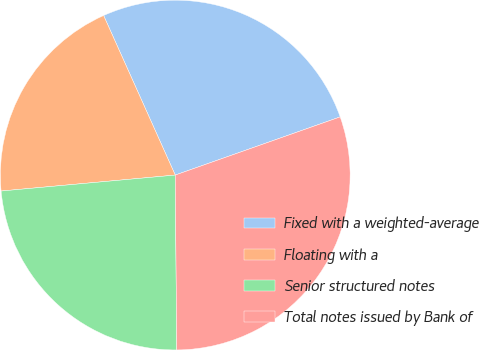<chart> <loc_0><loc_0><loc_500><loc_500><pie_chart><fcel>Fixed with a weighted-average<fcel>Floating with a<fcel>Senior structured notes<fcel>Total notes issued by Bank of<nl><fcel>26.32%<fcel>19.74%<fcel>23.68%<fcel>30.26%<nl></chart> 